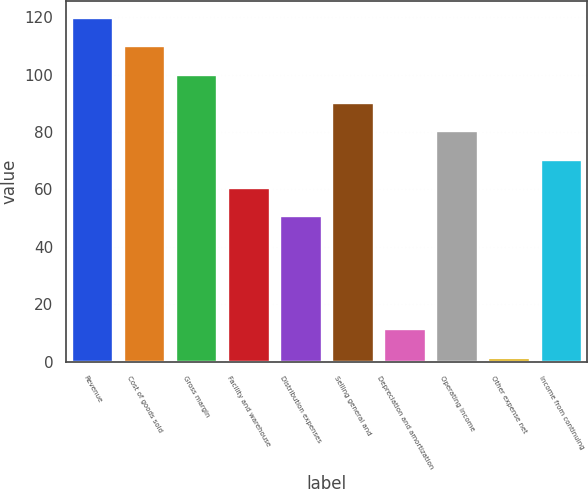Convert chart. <chart><loc_0><loc_0><loc_500><loc_500><bar_chart><fcel>Revenue<fcel>Cost of goods sold<fcel>Gross margin<fcel>Facility and warehouse<fcel>Distribution expenses<fcel>Selling general and<fcel>Depreciation and amortization<fcel>Operating income<fcel>Other expense net<fcel>Income from continuing<nl><fcel>119.74<fcel>109.87<fcel>100<fcel>60.52<fcel>50.65<fcel>90.13<fcel>11.17<fcel>80.26<fcel>1.3<fcel>70.39<nl></chart> 